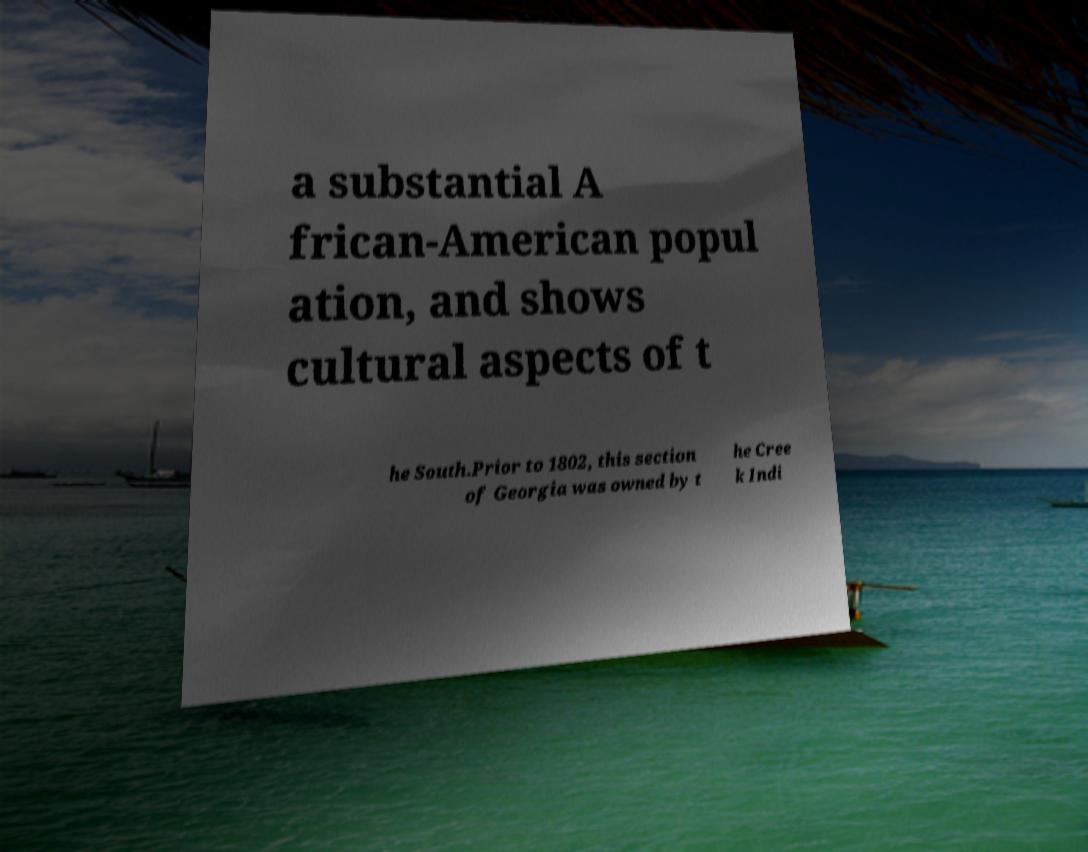Could you extract and type out the text from this image? a substantial A frican-American popul ation, and shows cultural aspects of t he South.Prior to 1802, this section of Georgia was owned by t he Cree k Indi 